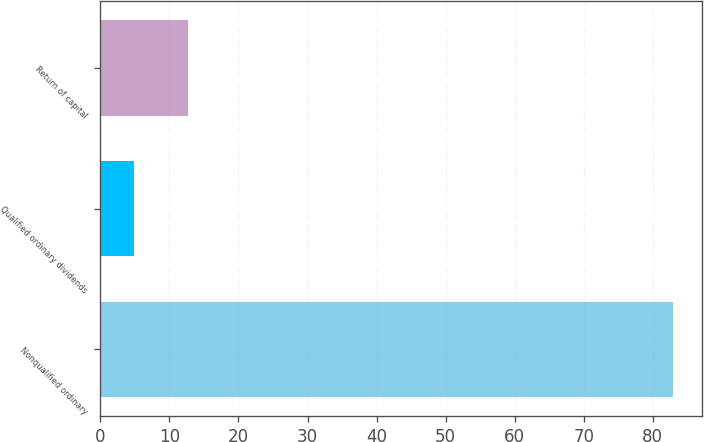<chart> <loc_0><loc_0><loc_500><loc_500><bar_chart><fcel>Nonqualified ordinary<fcel>Qualified ordinary dividends<fcel>Return of capital<nl><fcel>83<fcel>4.8<fcel>12.62<nl></chart> 